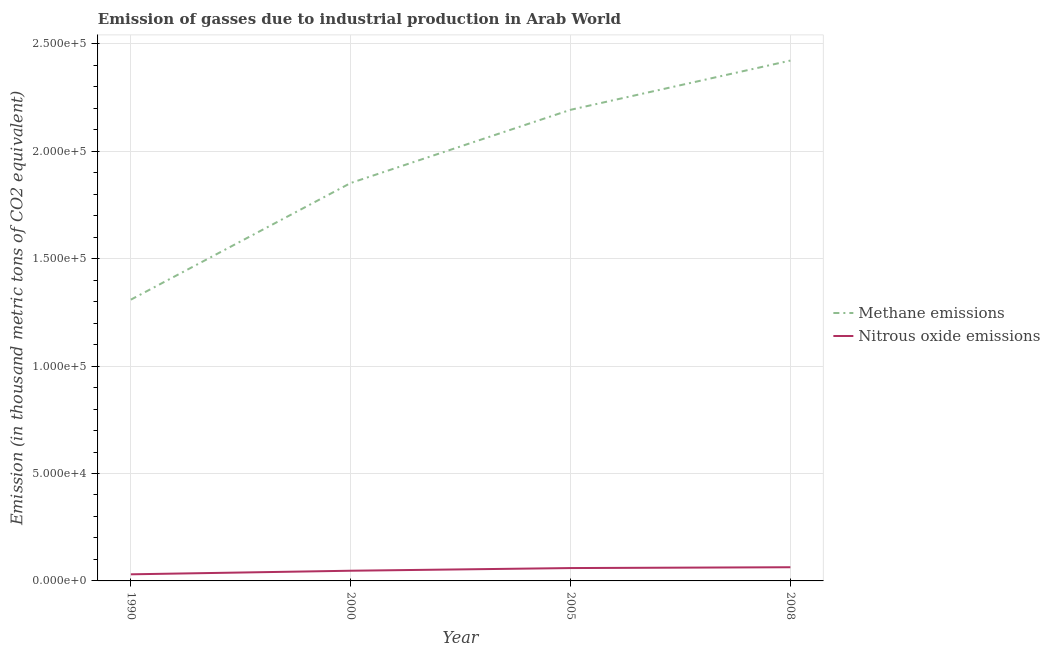How many different coloured lines are there?
Offer a very short reply. 2. Does the line corresponding to amount of nitrous oxide emissions intersect with the line corresponding to amount of methane emissions?
Make the answer very short. No. Is the number of lines equal to the number of legend labels?
Ensure brevity in your answer.  Yes. What is the amount of methane emissions in 1990?
Provide a succinct answer. 1.31e+05. Across all years, what is the maximum amount of nitrous oxide emissions?
Ensure brevity in your answer.  6368.1. Across all years, what is the minimum amount of methane emissions?
Make the answer very short. 1.31e+05. In which year was the amount of methane emissions maximum?
Make the answer very short. 2008. In which year was the amount of methane emissions minimum?
Make the answer very short. 1990. What is the total amount of nitrous oxide emissions in the graph?
Offer a terse response. 2.02e+04. What is the difference between the amount of methane emissions in 1990 and that in 2000?
Make the answer very short. -5.43e+04. What is the difference between the amount of nitrous oxide emissions in 1990 and the amount of methane emissions in 2000?
Provide a short and direct response. -1.82e+05. What is the average amount of nitrous oxide emissions per year?
Give a very brief answer. 5045.02. In the year 2008, what is the difference between the amount of nitrous oxide emissions and amount of methane emissions?
Ensure brevity in your answer.  -2.36e+05. What is the ratio of the amount of nitrous oxide emissions in 1990 to that in 2005?
Make the answer very short. 0.51. Is the amount of nitrous oxide emissions in 2000 less than that in 2005?
Your answer should be compact. Yes. What is the difference between the highest and the second highest amount of nitrous oxide emissions?
Make the answer very short. 379. What is the difference between the highest and the lowest amount of methane emissions?
Make the answer very short. 1.11e+05. Does the amount of nitrous oxide emissions monotonically increase over the years?
Give a very brief answer. Yes. What is the difference between two consecutive major ticks on the Y-axis?
Offer a very short reply. 5.00e+04. Are the values on the major ticks of Y-axis written in scientific E-notation?
Make the answer very short. Yes. Where does the legend appear in the graph?
Make the answer very short. Center right. How many legend labels are there?
Your answer should be compact. 2. How are the legend labels stacked?
Keep it short and to the point. Vertical. What is the title of the graph?
Your response must be concise. Emission of gasses due to industrial production in Arab World. Does "Automatic Teller Machines" appear as one of the legend labels in the graph?
Keep it short and to the point. No. What is the label or title of the X-axis?
Your response must be concise. Year. What is the label or title of the Y-axis?
Offer a terse response. Emission (in thousand metric tons of CO2 equivalent). What is the Emission (in thousand metric tons of CO2 equivalent) of Methane emissions in 1990?
Give a very brief answer. 1.31e+05. What is the Emission (in thousand metric tons of CO2 equivalent) of Nitrous oxide emissions in 1990?
Offer a terse response. 3077.4. What is the Emission (in thousand metric tons of CO2 equivalent) of Methane emissions in 2000?
Make the answer very short. 1.85e+05. What is the Emission (in thousand metric tons of CO2 equivalent) of Nitrous oxide emissions in 2000?
Your response must be concise. 4745.5. What is the Emission (in thousand metric tons of CO2 equivalent) in Methane emissions in 2005?
Make the answer very short. 2.19e+05. What is the Emission (in thousand metric tons of CO2 equivalent) of Nitrous oxide emissions in 2005?
Your response must be concise. 5989.1. What is the Emission (in thousand metric tons of CO2 equivalent) of Methane emissions in 2008?
Offer a very short reply. 2.42e+05. What is the Emission (in thousand metric tons of CO2 equivalent) in Nitrous oxide emissions in 2008?
Offer a very short reply. 6368.1. Across all years, what is the maximum Emission (in thousand metric tons of CO2 equivalent) in Methane emissions?
Offer a very short reply. 2.42e+05. Across all years, what is the maximum Emission (in thousand metric tons of CO2 equivalent) in Nitrous oxide emissions?
Keep it short and to the point. 6368.1. Across all years, what is the minimum Emission (in thousand metric tons of CO2 equivalent) of Methane emissions?
Give a very brief answer. 1.31e+05. Across all years, what is the minimum Emission (in thousand metric tons of CO2 equivalent) in Nitrous oxide emissions?
Offer a very short reply. 3077.4. What is the total Emission (in thousand metric tons of CO2 equivalent) in Methane emissions in the graph?
Your response must be concise. 7.78e+05. What is the total Emission (in thousand metric tons of CO2 equivalent) of Nitrous oxide emissions in the graph?
Your answer should be very brief. 2.02e+04. What is the difference between the Emission (in thousand metric tons of CO2 equivalent) in Methane emissions in 1990 and that in 2000?
Provide a short and direct response. -5.43e+04. What is the difference between the Emission (in thousand metric tons of CO2 equivalent) of Nitrous oxide emissions in 1990 and that in 2000?
Your response must be concise. -1668.1. What is the difference between the Emission (in thousand metric tons of CO2 equivalent) in Methane emissions in 1990 and that in 2005?
Provide a short and direct response. -8.84e+04. What is the difference between the Emission (in thousand metric tons of CO2 equivalent) of Nitrous oxide emissions in 1990 and that in 2005?
Your response must be concise. -2911.7. What is the difference between the Emission (in thousand metric tons of CO2 equivalent) of Methane emissions in 1990 and that in 2008?
Your response must be concise. -1.11e+05. What is the difference between the Emission (in thousand metric tons of CO2 equivalent) in Nitrous oxide emissions in 1990 and that in 2008?
Provide a short and direct response. -3290.7. What is the difference between the Emission (in thousand metric tons of CO2 equivalent) in Methane emissions in 2000 and that in 2005?
Give a very brief answer. -3.41e+04. What is the difference between the Emission (in thousand metric tons of CO2 equivalent) of Nitrous oxide emissions in 2000 and that in 2005?
Offer a terse response. -1243.6. What is the difference between the Emission (in thousand metric tons of CO2 equivalent) in Methane emissions in 2000 and that in 2008?
Provide a short and direct response. -5.70e+04. What is the difference between the Emission (in thousand metric tons of CO2 equivalent) of Nitrous oxide emissions in 2000 and that in 2008?
Provide a short and direct response. -1622.6. What is the difference between the Emission (in thousand metric tons of CO2 equivalent) of Methane emissions in 2005 and that in 2008?
Provide a short and direct response. -2.29e+04. What is the difference between the Emission (in thousand metric tons of CO2 equivalent) of Nitrous oxide emissions in 2005 and that in 2008?
Provide a succinct answer. -379. What is the difference between the Emission (in thousand metric tons of CO2 equivalent) in Methane emissions in 1990 and the Emission (in thousand metric tons of CO2 equivalent) in Nitrous oxide emissions in 2000?
Ensure brevity in your answer.  1.26e+05. What is the difference between the Emission (in thousand metric tons of CO2 equivalent) of Methane emissions in 1990 and the Emission (in thousand metric tons of CO2 equivalent) of Nitrous oxide emissions in 2005?
Provide a succinct answer. 1.25e+05. What is the difference between the Emission (in thousand metric tons of CO2 equivalent) of Methane emissions in 1990 and the Emission (in thousand metric tons of CO2 equivalent) of Nitrous oxide emissions in 2008?
Keep it short and to the point. 1.25e+05. What is the difference between the Emission (in thousand metric tons of CO2 equivalent) in Methane emissions in 2000 and the Emission (in thousand metric tons of CO2 equivalent) in Nitrous oxide emissions in 2005?
Offer a terse response. 1.79e+05. What is the difference between the Emission (in thousand metric tons of CO2 equivalent) of Methane emissions in 2000 and the Emission (in thousand metric tons of CO2 equivalent) of Nitrous oxide emissions in 2008?
Ensure brevity in your answer.  1.79e+05. What is the difference between the Emission (in thousand metric tons of CO2 equivalent) of Methane emissions in 2005 and the Emission (in thousand metric tons of CO2 equivalent) of Nitrous oxide emissions in 2008?
Make the answer very short. 2.13e+05. What is the average Emission (in thousand metric tons of CO2 equivalent) in Methane emissions per year?
Your answer should be compact. 1.94e+05. What is the average Emission (in thousand metric tons of CO2 equivalent) of Nitrous oxide emissions per year?
Offer a very short reply. 5045.02. In the year 1990, what is the difference between the Emission (in thousand metric tons of CO2 equivalent) of Methane emissions and Emission (in thousand metric tons of CO2 equivalent) of Nitrous oxide emissions?
Provide a short and direct response. 1.28e+05. In the year 2000, what is the difference between the Emission (in thousand metric tons of CO2 equivalent) in Methane emissions and Emission (in thousand metric tons of CO2 equivalent) in Nitrous oxide emissions?
Your response must be concise. 1.80e+05. In the year 2005, what is the difference between the Emission (in thousand metric tons of CO2 equivalent) of Methane emissions and Emission (in thousand metric tons of CO2 equivalent) of Nitrous oxide emissions?
Keep it short and to the point. 2.13e+05. In the year 2008, what is the difference between the Emission (in thousand metric tons of CO2 equivalent) in Methane emissions and Emission (in thousand metric tons of CO2 equivalent) in Nitrous oxide emissions?
Your response must be concise. 2.36e+05. What is the ratio of the Emission (in thousand metric tons of CO2 equivalent) in Methane emissions in 1990 to that in 2000?
Offer a very short reply. 0.71. What is the ratio of the Emission (in thousand metric tons of CO2 equivalent) of Nitrous oxide emissions in 1990 to that in 2000?
Keep it short and to the point. 0.65. What is the ratio of the Emission (in thousand metric tons of CO2 equivalent) in Methane emissions in 1990 to that in 2005?
Keep it short and to the point. 0.6. What is the ratio of the Emission (in thousand metric tons of CO2 equivalent) of Nitrous oxide emissions in 1990 to that in 2005?
Provide a short and direct response. 0.51. What is the ratio of the Emission (in thousand metric tons of CO2 equivalent) of Methane emissions in 1990 to that in 2008?
Provide a short and direct response. 0.54. What is the ratio of the Emission (in thousand metric tons of CO2 equivalent) in Nitrous oxide emissions in 1990 to that in 2008?
Offer a terse response. 0.48. What is the ratio of the Emission (in thousand metric tons of CO2 equivalent) of Methane emissions in 2000 to that in 2005?
Provide a short and direct response. 0.84. What is the ratio of the Emission (in thousand metric tons of CO2 equivalent) in Nitrous oxide emissions in 2000 to that in 2005?
Offer a very short reply. 0.79. What is the ratio of the Emission (in thousand metric tons of CO2 equivalent) of Methane emissions in 2000 to that in 2008?
Provide a short and direct response. 0.76. What is the ratio of the Emission (in thousand metric tons of CO2 equivalent) in Nitrous oxide emissions in 2000 to that in 2008?
Your answer should be very brief. 0.75. What is the ratio of the Emission (in thousand metric tons of CO2 equivalent) in Methane emissions in 2005 to that in 2008?
Offer a terse response. 0.91. What is the ratio of the Emission (in thousand metric tons of CO2 equivalent) of Nitrous oxide emissions in 2005 to that in 2008?
Your answer should be compact. 0.94. What is the difference between the highest and the second highest Emission (in thousand metric tons of CO2 equivalent) of Methane emissions?
Your response must be concise. 2.29e+04. What is the difference between the highest and the second highest Emission (in thousand metric tons of CO2 equivalent) in Nitrous oxide emissions?
Your answer should be compact. 379. What is the difference between the highest and the lowest Emission (in thousand metric tons of CO2 equivalent) of Methane emissions?
Offer a very short reply. 1.11e+05. What is the difference between the highest and the lowest Emission (in thousand metric tons of CO2 equivalent) in Nitrous oxide emissions?
Offer a very short reply. 3290.7. 